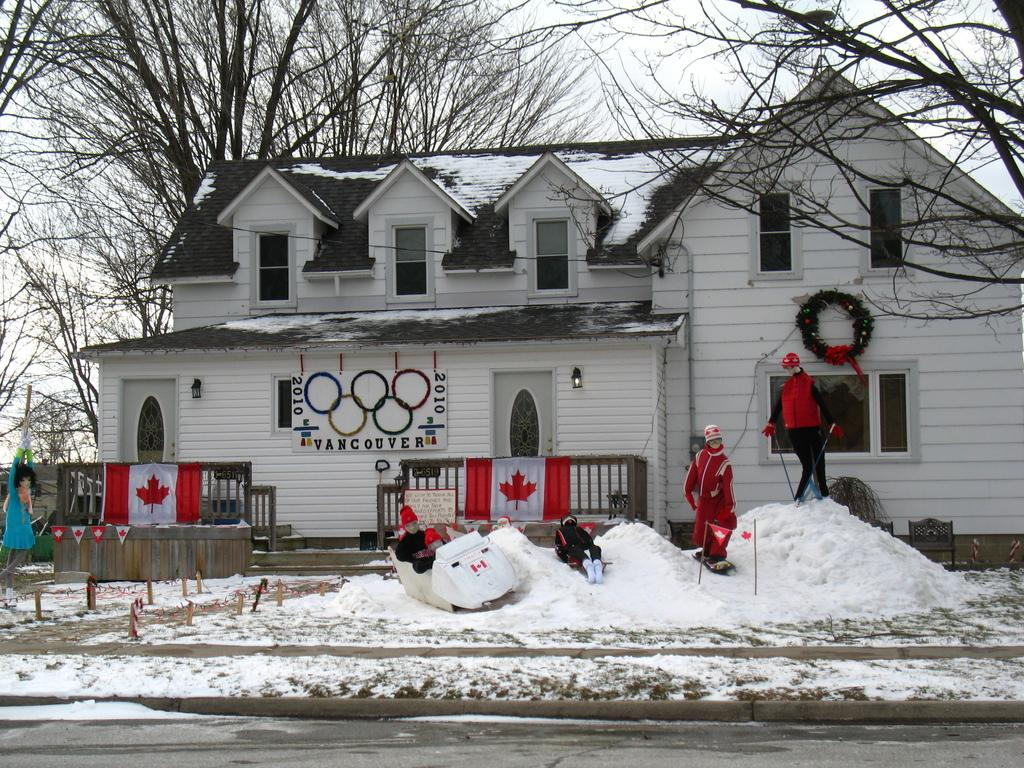What is the predominant weather condition in the image? There is snow in the image, indicating a cold and wintry setting. What type of figures can be seen in the image? There are scarecrows in the image. What can be seen in the distance in the image? There are trees, a house, flags, and a hoarding in the background of the image. What type of dress is the scarecrow wearing in the image? The scarecrows in the image do not have clothing or dresses, as they are made of straw and other materials. 